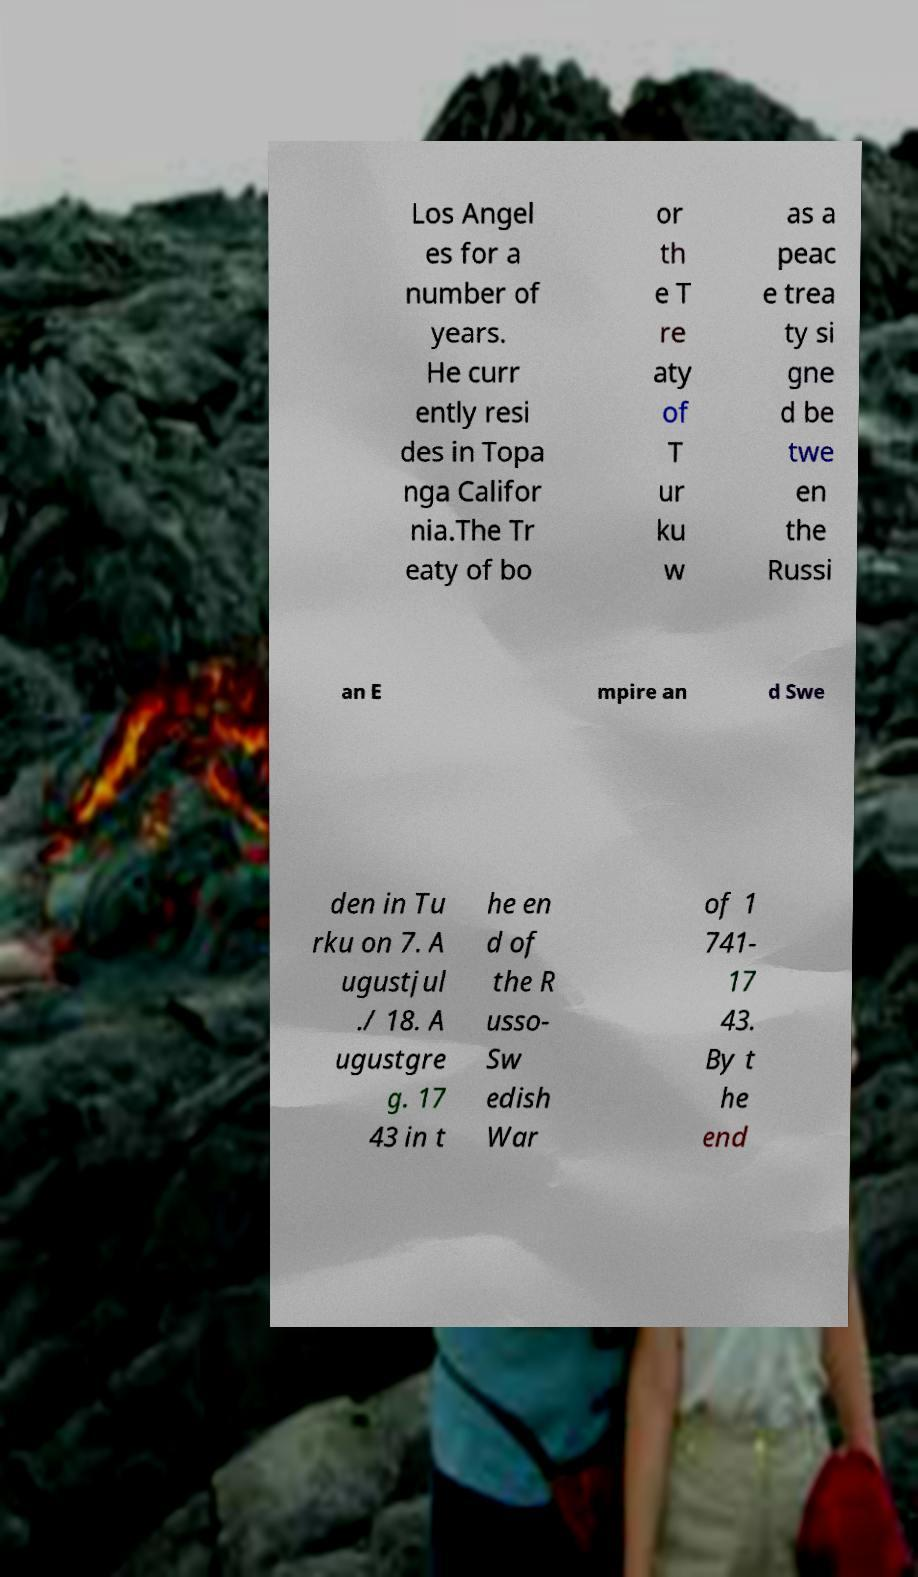There's text embedded in this image that I need extracted. Can you transcribe it verbatim? Los Angel es for a number of years. He curr ently resi des in Topa nga Califor nia.The Tr eaty of bo or th e T re aty of T ur ku w as a peac e trea ty si gne d be twe en the Russi an E mpire an d Swe den in Tu rku on 7. A ugustjul ./ 18. A ugustgre g. 17 43 in t he en d of the R usso- Sw edish War of 1 741- 17 43. By t he end 